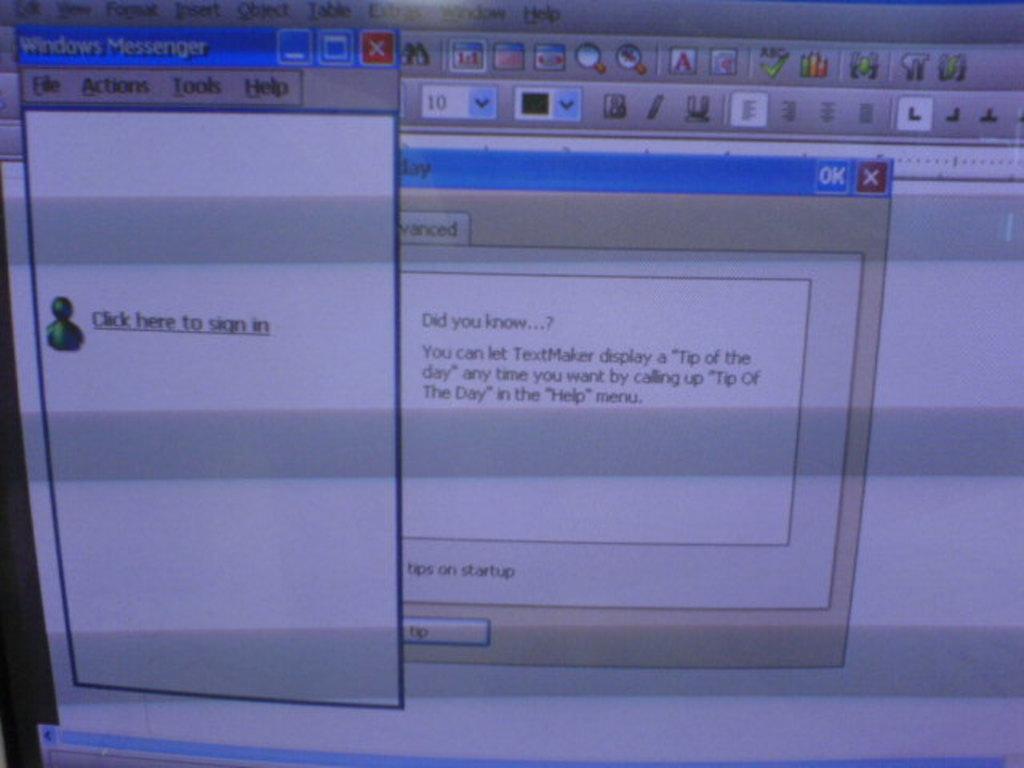What does it tell you to do to sign in?
Make the answer very short. Click here. What does text maker do?
Your response must be concise. Sign in. 